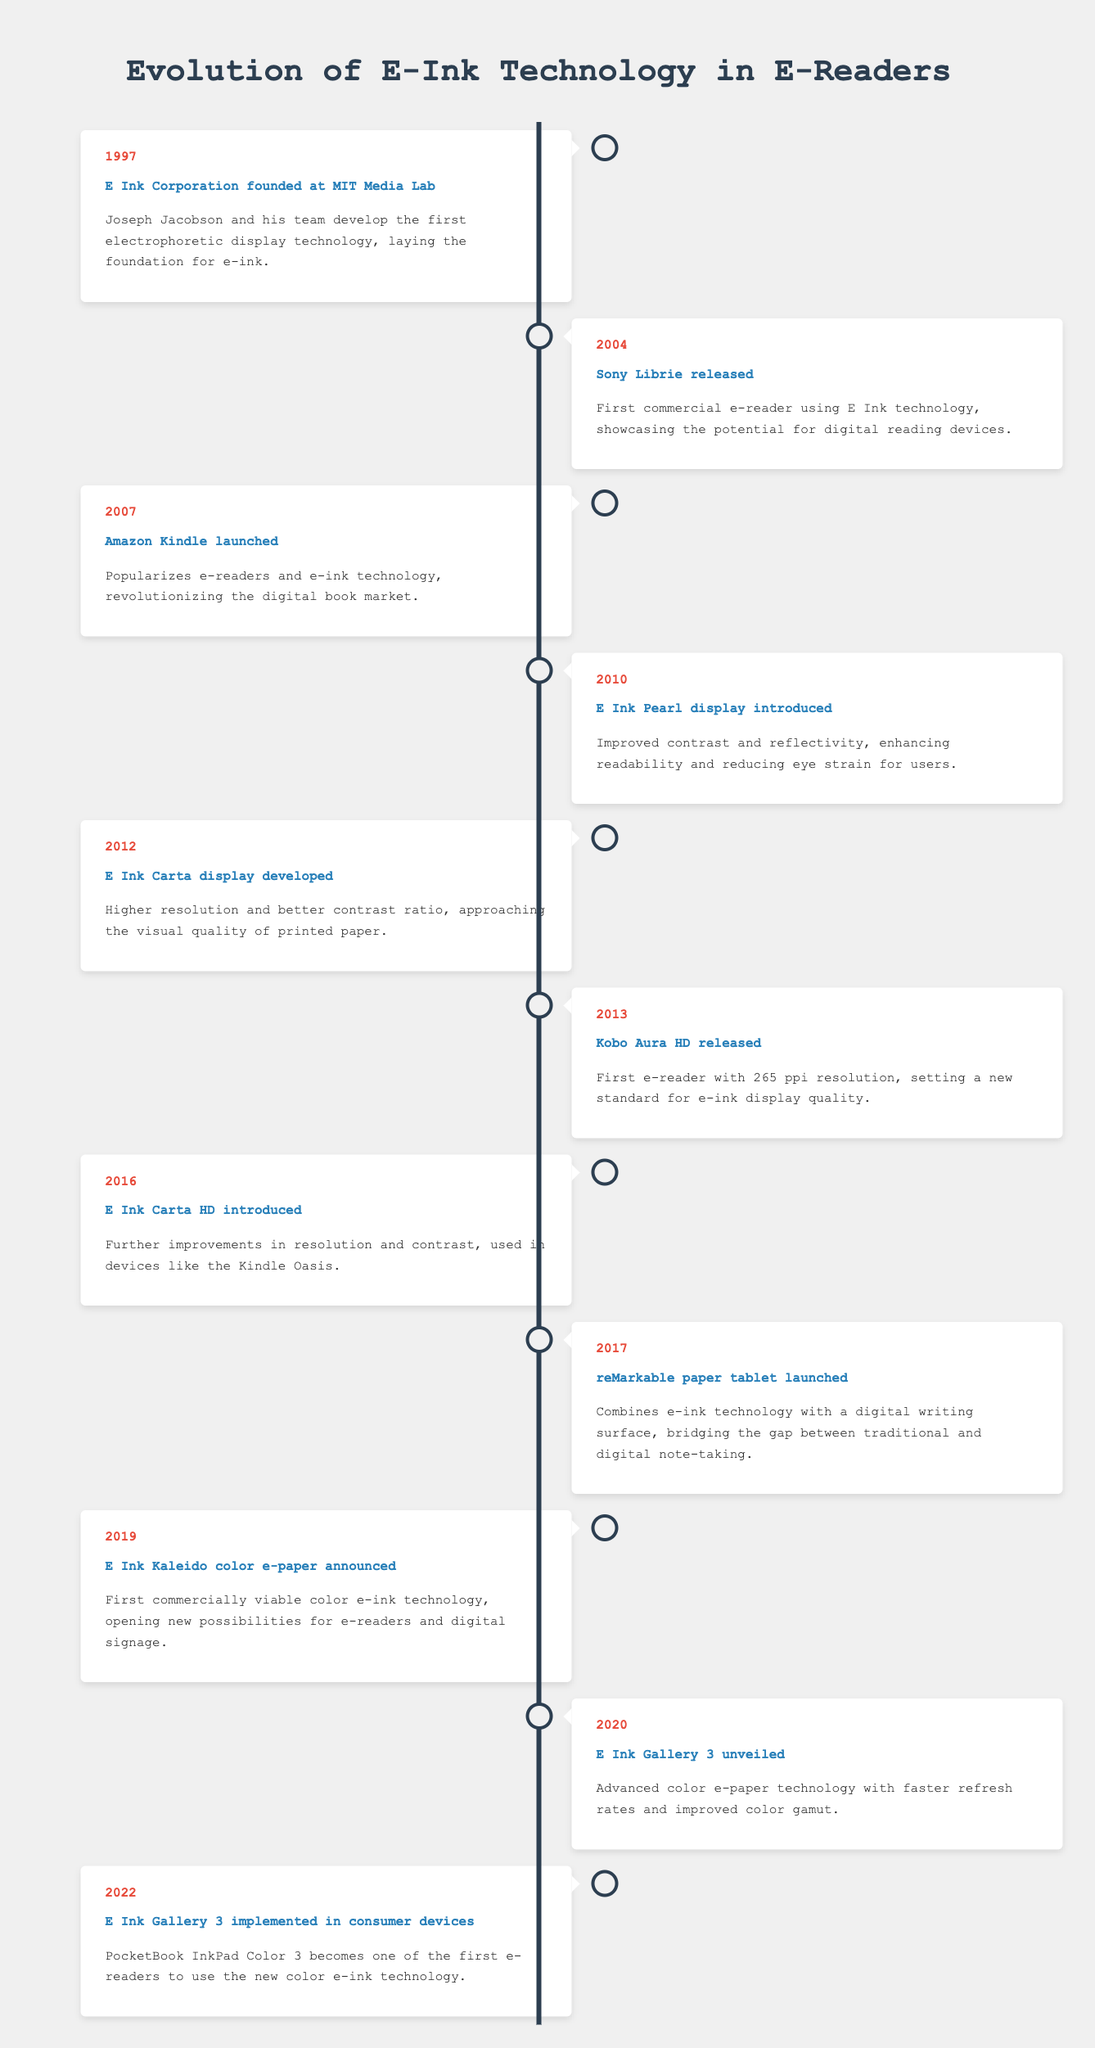What year was E Ink Corporation founded? The table states that E Ink Corporation was founded in 1997.
Answer: 1997 What was the first e-reader to use E Ink technology? According to the table, the first commercial e-reader using E Ink technology was the Sony Librie, released in 2004.
Answer: Sony Librie Which e-reader set a new standard for display quality with 265 ppi resolution? The table indicates that the Kobo Aura HD, released in 2013, was the first e-reader with a resolution of 265 ppi.
Answer: Kobo Aura HD Was E Ink technology used in e-readers before 2007? As per the events listed in the table, the Sony Librie, released in 2004, was the first e-reader to use E Ink technology. Hence, it indicates that yes, E Ink technology was used before 2007.
Answer: Yes How many years passed between the introduction of the E Ink Pearl display and the launch of the Amazon Kindle? The E Ink Pearl display was introduced in 2010 and the Amazon Kindle was launched in 2007. To find the difference: 2010 - 2007 = 3 years.
Answer: 3 years What event marked the commercial viability of color e-ink technology? The table shows that the E Ink Kaleido color e-paper was announced in 2019, marking the first commercially viable color e-ink technology.
Answer: E Ink Kaleido announcement In which year was the reMarkable paper tablet launched? The timeline denotes that the reMarkable paper tablet was launched in 2017.
Answer: 2017 Which display had improved color gamut and faster refresh rates, launched in 2020? The table states that the E Ink Gallery 3, unveiled in 2020, features advanced color e-paper technology with faster refresh rates and improved color gamut.
Answer: E Ink Gallery 3 How many unique e-ink display technologies were introduced between 2010 and 2020? Referring to the timeline, two unique e-ink display technologies, E Ink Pearl (2010) and E Ink Gallery 3 (2020), were introduced within that time frame. Therefore, we include: E Ink Pearl, E Ink Carta HD, and E Ink Gallery 3. That gives us three unique displays: two in 2010 and one in 2020.
Answer: 3 